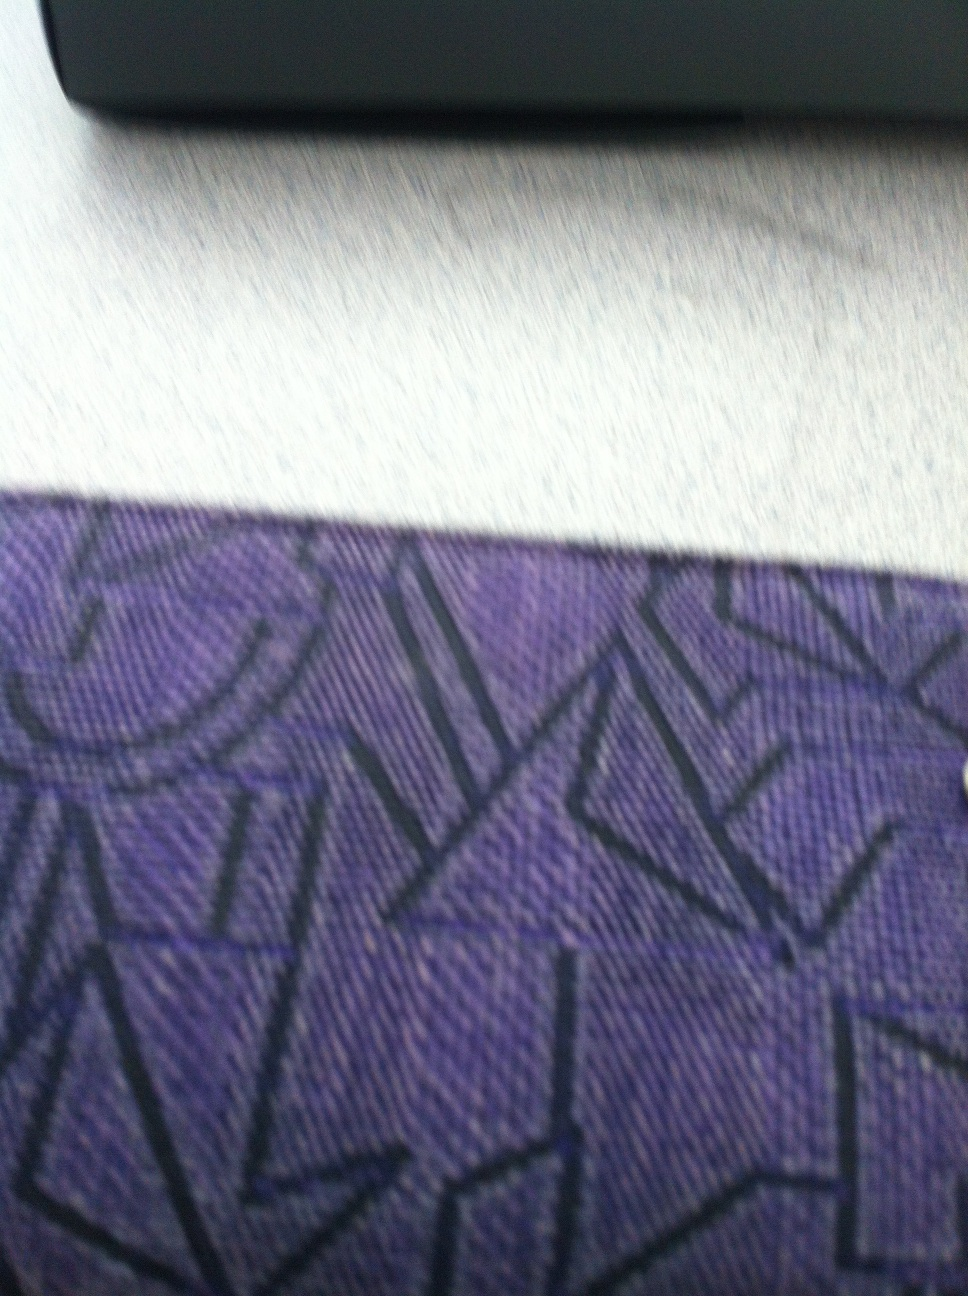If this wallet could talk, what secrets might it reveal? If the wallet could speak, it might whisper tales of the countless hands that have held it, the different currencies it has carried, and the secrets it has overheard. It might reveal a hidden compartment where a cherished memento is kept, or the instance it was almost left behind in a far-off land. This wallet, with its geometric design, might also confide in the dreams and aspirations of its owner, tucked away in the folds of its fabric. Wow, that's fascinating! How do you think it ended up in my possession? The journey of your wallet to your possession is one of serendipity. Perhaps it was a gift from a dear friend who knew your affinity for unique designs, or maybe you stumbled upon it in a quaint boutique while traveling. It could also be that it was an heirloom, passed down to you with stories of its own, now ready to be a part of your life's adventures. 